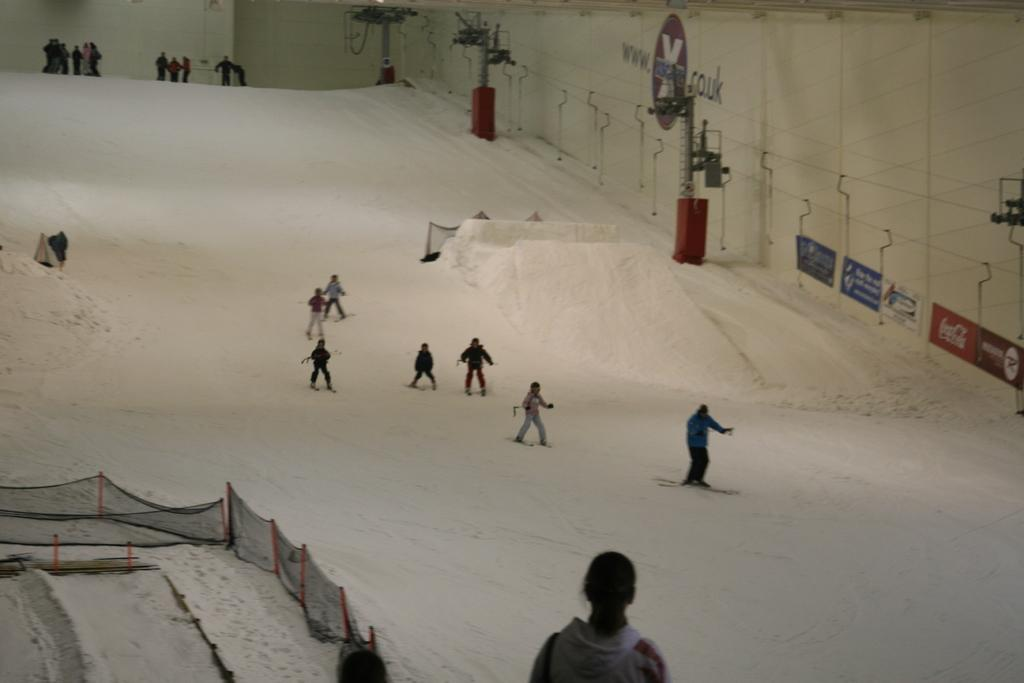What activity are the people in the image engaged in? The people in the image are skating on the ice. Can you describe any structures or objects on the left side of the image? There is a railing on the left side of the image. What can be seen in the background of the image? There are boards attached to the wall in the background of the image. What type of bed is visible in the image? There is no bed present in the image; it features people skating on the ice. What policy changes does the governor propose in the image? There is no governor or policy changes mentioned in the image; it focuses on people skating on the ice and the surrounding structures. 